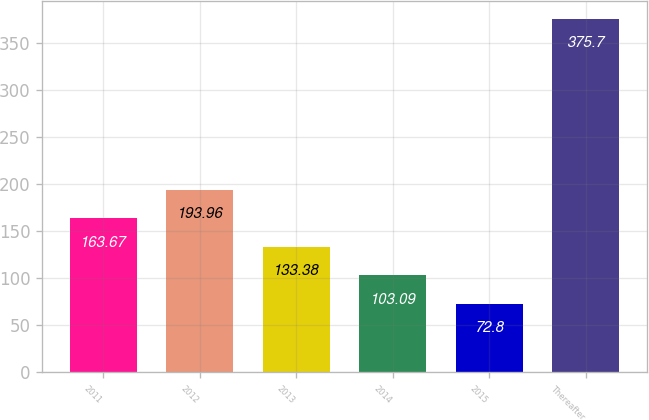Convert chart to OTSL. <chart><loc_0><loc_0><loc_500><loc_500><bar_chart><fcel>2011<fcel>2012<fcel>2013<fcel>2014<fcel>2015<fcel>Thereafter<nl><fcel>163.67<fcel>193.96<fcel>133.38<fcel>103.09<fcel>72.8<fcel>375.7<nl></chart> 